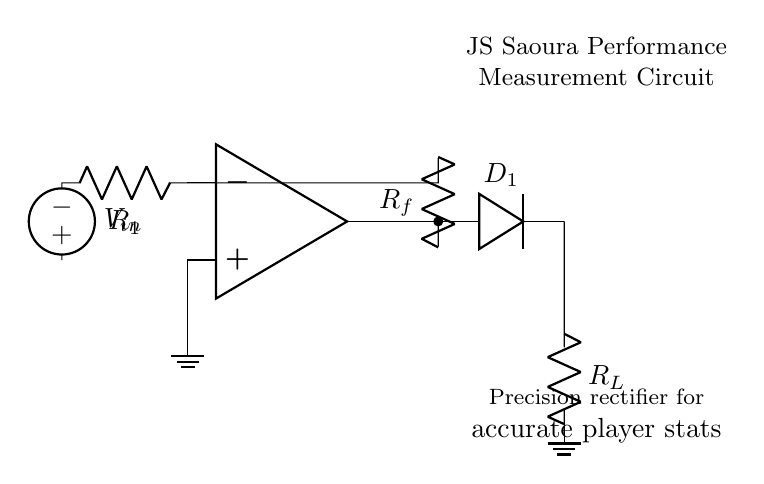What type of amplifier is used in this circuit? The circuit uses an operational amplifier (op-amp), shown at the left side with the label in the diagram.
Answer: operational amplifier What does the component labeled D1 represent? D1 in the circuit is a diode, indicated in the diagram, which allows current to flow in one direction, essential for rectification.
Answer: diode What is the function of the resistor labeled R1? R1 serves as a feedback resistor, critical in controlling the gain of the amplifier and influencing the output voltage.
Answer: feedback resistor What is the role of the load resistor R_L? R_L, labeled at the bottom of the diagram, is connected to the output and provides the load for the precision rectifier circuit, affecting the current flow.
Answer: load resistor Why is this circuit called a precision rectifier? This circuit is termed a precision rectifier due to the op-amp's ability to output low-voltage signals with high accuracy, allowing for precise measurement of player performance.
Answer: high accuracy How is the input voltage source configured in the circuit? The input voltage source V_in is connected to the non-inverting input of the op-amp, assisting in amplifying the input signal before rectification.
Answer: connected to non-inverting input What type of output does this circuit produce? The output of this circuit is a rectified voltage, which is a positive version of the input signal, allowing for accurate measurements.
Answer: rectified voltage 